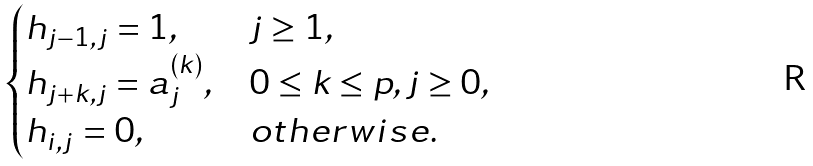<formula> <loc_0><loc_0><loc_500><loc_500>\begin{cases} h _ { j - 1 , j } = 1 , & j \geq 1 , \\ h _ { j + k , j } = a _ { j } ^ { ( k ) } , & 0 \leq k \leq p , j \geq 0 , \\ h _ { i , j } = 0 , & o t h e r w i s e . \end{cases}</formula> 